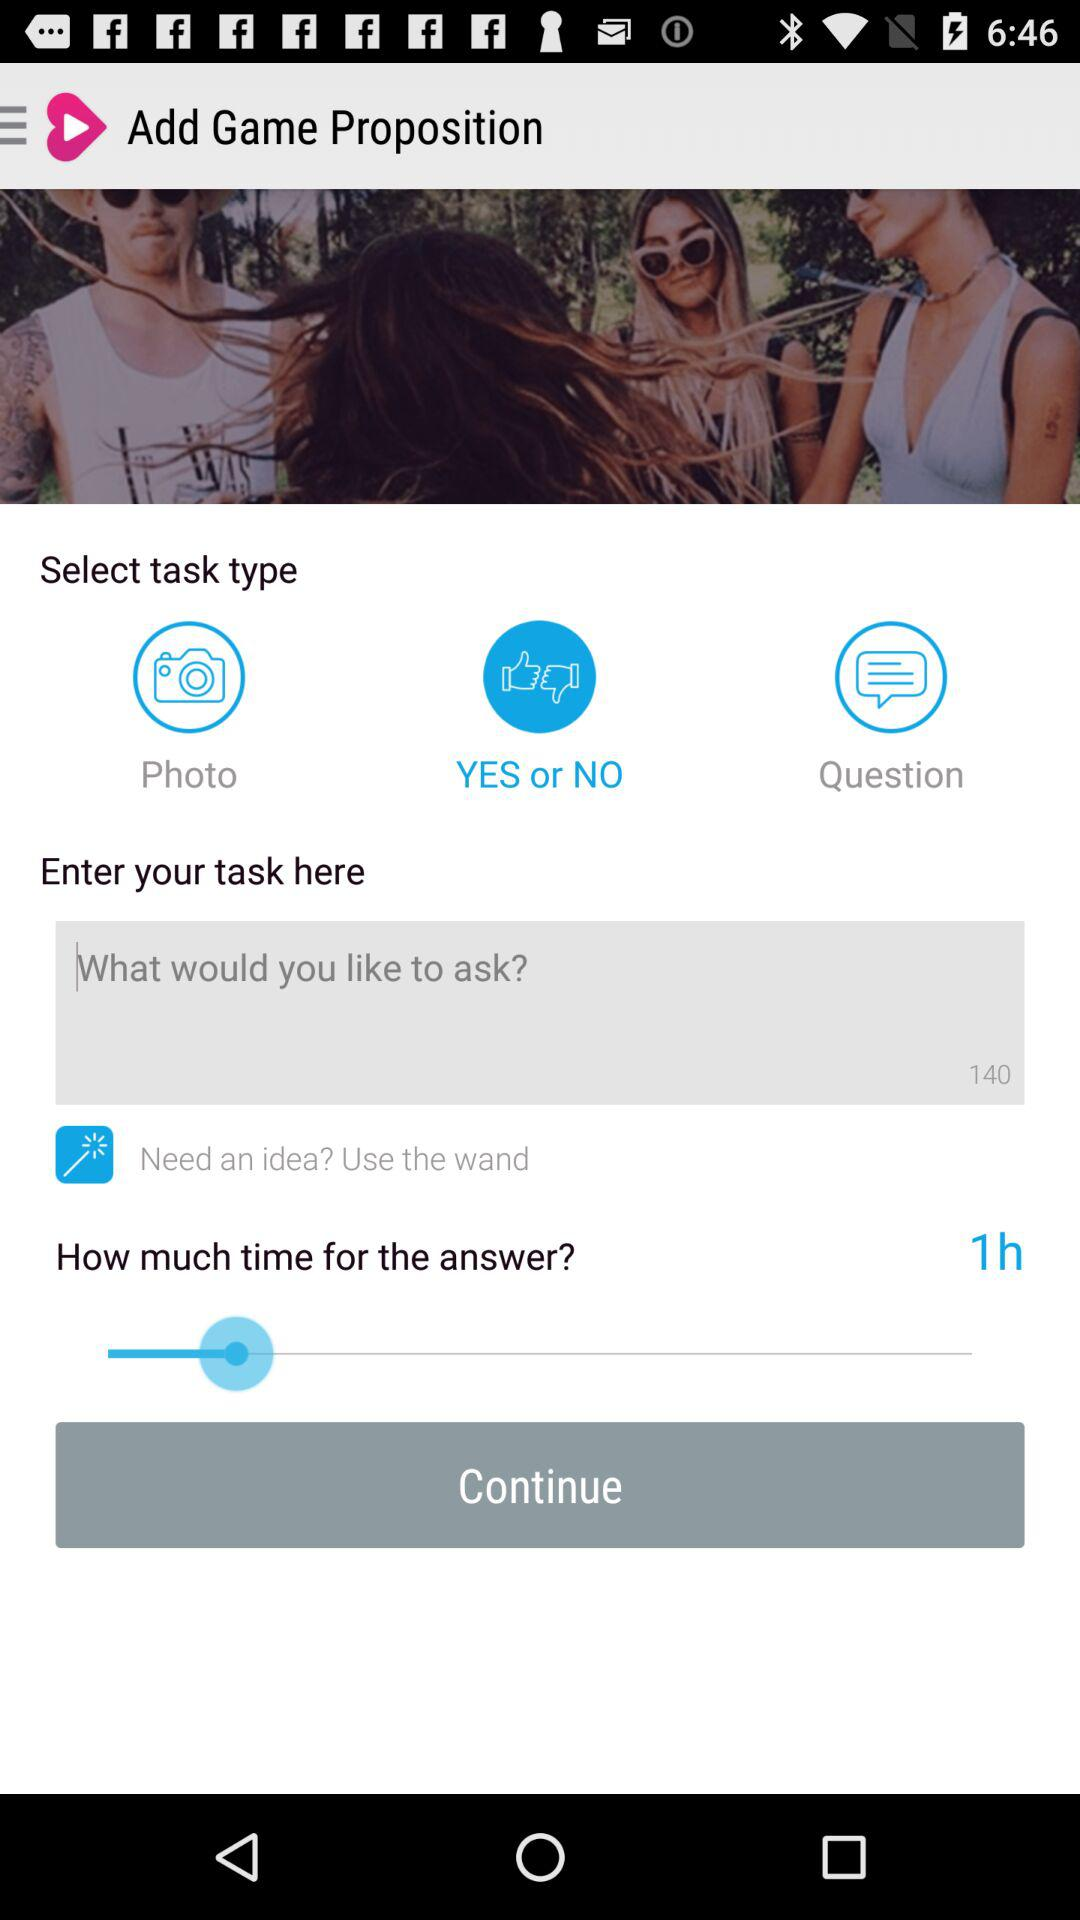Which task type is selected? The selected task type is "YES or NO". 